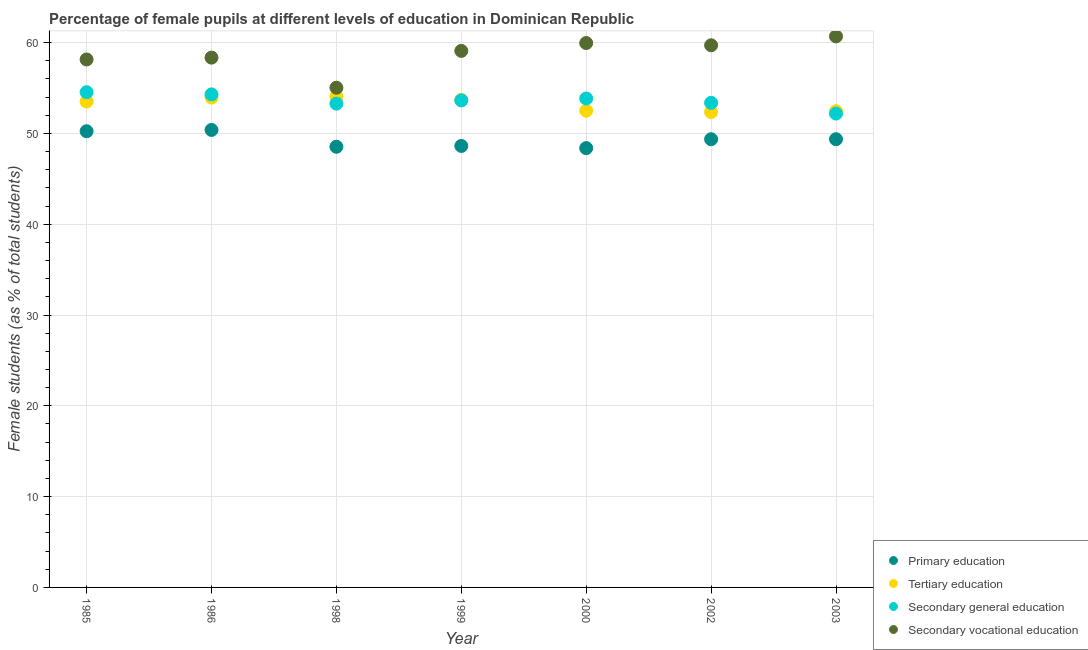How many different coloured dotlines are there?
Provide a short and direct response. 4. What is the percentage of female students in tertiary education in 1999?
Offer a very short reply. 53.7. Across all years, what is the maximum percentage of female students in secondary vocational education?
Your answer should be compact. 60.68. Across all years, what is the minimum percentage of female students in primary education?
Offer a terse response. 48.38. In which year was the percentage of female students in tertiary education maximum?
Your response must be concise. 1998. In which year was the percentage of female students in primary education minimum?
Your response must be concise. 2000. What is the total percentage of female students in primary education in the graph?
Give a very brief answer. 344.88. What is the difference between the percentage of female students in secondary vocational education in 1985 and that in 1986?
Offer a terse response. -0.2. What is the difference between the percentage of female students in tertiary education in 2002 and the percentage of female students in primary education in 1998?
Your response must be concise. 3.82. What is the average percentage of female students in tertiary education per year?
Your answer should be compact. 53.22. In the year 1999, what is the difference between the percentage of female students in tertiary education and percentage of female students in primary education?
Your response must be concise. 5.08. In how many years, is the percentage of female students in secondary education greater than 46 %?
Give a very brief answer. 7. What is the ratio of the percentage of female students in secondary education in 1985 to that in 2000?
Offer a very short reply. 1.01. Is the percentage of female students in secondary vocational education in 1998 less than that in 2002?
Your answer should be compact. Yes. Is the difference between the percentage of female students in secondary vocational education in 1985 and 2002 greater than the difference between the percentage of female students in primary education in 1985 and 2002?
Your response must be concise. No. What is the difference between the highest and the second highest percentage of female students in secondary education?
Your response must be concise. 0.24. What is the difference between the highest and the lowest percentage of female students in secondary vocational education?
Your response must be concise. 5.65. Is the sum of the percentage of female students in secondary education in 1986 and 2000 greater than the maximum percentage of female students in tertiary education across all years?
Provide a succinct answer. Yes. Is it the case that in every year, the sum of the percentage of female students in primary education and percentage of female students in tertiary education is greater than the sum of percentage of female students in secondary education and percentage of female students in secondary vocational education?
Give a very brief answer. Yes. Is it the case that in every year, the sum of the percentage of female students in primary education and percentage of female students in tertiary education is greater than the percentage of female students in secondary education?
Provide a short and direct response. Yes. Does the percentage of female students in secondary vocational education monotonically increase over the years?
Ensure brevity in your answer.  No. Is the percentage of female students in primary education strictly less than the percentage of female students in secondary vocational education over the years?
Your answer should be compact. Yes. How many years are there in the graph?
Offer a terse response. 7. What is the difference between two consecutive major ticks on the Y-axis?
Ensure brevity in your answer.  10. Are the values on the major ticks of Y-axis written in scientific E-notation?
Offer a very short reply. No. Does the graph contain grids?
Offer a terse response. Yes. Where does the legend appear in the graph?
Provide a succinct answer. Bottom right. How many legend labels are there?
Your response must be concise. 4. What is the title of the graph?
Make the answer very short. Percentage of female pupils at different levels of education in Dominican Republic. Does "Environmental sustainability" appear as one of the legend labels in the graph?
Offer a terse response. No. What is the label or title of the X-axis?
Ensure brevity in your answer.  Year. What is the label or title of the Y-axis?
Offer a terse response. Female students (as % of total students). What is the Female students (as % of total students) in Primary education in 1985?
Offer a very short reply. 50.24. What is the Female students (as % of total students) in Tertiary education in 1985?
Provide a succinct answer. 53.51. What is the Female students (as % of total students) in Secondary general education in 1985?
Offer a very short reply. 54.54. What is the Female students (as % of total students) in Secondary vocational education in 1985?
Provide a succinct answer. 58.14. What is the Female students (as % of total students) of Primary education in 1986?
Provide a succinct answer. 50.38. What is the Female students (as % of total students) of Tertiary education in 1986?
Your answer should be very brief. 53.95. What is the Female students (as % of total students) of Secondary general education in 1986?
Make the answer very short. 54.3. What is the Female students (as % of total students) of Secondary vocational education in 1986?
Your response must be concise. 58.35. What is the Female students (as % of total students) of Primary education in 1998?
Give a very brief answer. 48.53. What is the Female students (as % of total students) of Tertiary education in 1998?
Keep it short and to the point. 54.07. What is the Female students (as % of total students) in Secondary general education in 1998?
Keep it short and to the point. 53.28. What is the Female students (as % of total students) in Secondary vocational education in 1998?
Ensure brevity in your answer.  55.03. What is the Female students (as % of total students) of Primary education in 1999?
Your response must be concise. 48.62. What is the Female students (as % of total students) in Tertiary education in 1999?
Make the answer very short. 53.7. What is the Female students (as % of total students) of Secondary general education in 1999?
Provide a succinct answer. 53.64. What is the Female students (as % of total students) in Secondary vocational education in 1999?
Give a very brief answer. 59.09. What is the Female students (as % of total students) of Primary education in 2000?
Ensure brevity in your answer.  48.38. What is the Female students (as % of total students) of Tertiary education in 2000?
Give a very brief answer. 52.5. What is the Female students (as % of total students) of Secondary general education in 2000?
Provide a succinct answer. 53.85. What is the Female students (as % of total students) in Secondary vocational education in 2000?
Provide a short and direct response. 59.95. What is the Female students (as % of total students) of Primary education in 2002?
Your response must be concise. 49.36. What is the Female students (as % of total students) of Tertiary education in 2002?
Ensure brevity in your answer.  52.35. What is the Female students (as % of total students) in Secondary general education in 2002?
Make the answer very short. 53.37. What is the Female students (as % of total students) of Secondary vocational education in 2002?
Provide a short and direct response. 59.71. What is the Female students (as % of total students) of Primary education in 2003?
Keep it short and to the point. 49.36. What is the Female students (as % of total students) in Tertiary education in 2003?
Provide a short and direct response. 52.44. What is the Female students (as % of total students) in Secondary general education in 2003?
Offer a terse response. 52.19. What is the Female students (as % of total students) of Secondary vocational education in 2003?
Your answer should be very brief. 60.68. Across all years, what is the maximum Female students (as % of total students) of Primary education?
Your answer should be compact. 50.38. Across all years, what is the maximum Female students (as % of total students) in Tertiary education?
Keep it short and to the point. 54.07. Across all years, what is the maximum Female students (as % of total students) in Secondary general education?
Your answer should be very brief. 54.54. Across all years, what is the maximum Female students (as % of total students) of Secondary vocational education?
Provide a succinct answer. 60.68. Across all years, what is the minimum Female students (as % of total students) of Primary education?
Give a very brief answer. 48.38. Across all years, what is the minimum Female students (as % of total students) of Tertiary education?
Your response must be concise. 52.35. Across all years, what is the minimum Female students (as % of total students) of Secondary general education?
Give a very brief answer. 52.19. Across all years, what is the minimum Female students (as % of total students) of Secondary vocational education?
Offer a very short reply. 55.03. What is the total Female students (as % of total students) in Primary education in the graph?
Your response must be concise. 344.88. What is the total Female students (as % of total students) in Tertiary education in the graph?
Make the answer very short. 372.53. What is the total Female students (as % of total students) of Secondary general education in the graph?
Your answer should be very brief. 375.16. What is the total Female students (as % of total students) of Secondary vocational education in the graph?
Make the answer very short. 410.96. What is the difference between the Female students (as % of total students) of Primary education in 1985 and that in 1986?
Ensure brevity in your answer.  -0.14. What is the difference between the Female students (as % of total students) of Tertiary education in 1985 and that in 1986?
Provide a short and direct response. -0.44. What is the difference between the Female students (as % of total students) in Secondary general education in 1985 and that in 1986?
Ensure brevity in your answer.  0.24. What is the difference between the Female students (as % of total students) of Secondary vocational education in 1985 and that in 1986?
Offer a terse response. -0.2. What is the difference between the Female students (as % of total students) in Primary education in 1985 and that in 1998?
Keep it short and to the point. 1.71. What is the difference between the Female students (as % of total students) of Tertiary education in 1985 and that in 1998?
Give a very brief answer. -0.56. What is the difference between the Female students (as % of total students) in Secondary general education in 1985 and that in 1998?
Provide a short and direct response. 1.26. What is the difference between the Female students (as % of total students) in Secondary vocational education in 1985 and that in 1998?
Give a very brief answer. 3.11. What is the difference between the Female students (as % of total students) in Primary education in 1985 and that in 1999?
Offer a very short reply. 1.62. What is the difference between the Female students (as % of total students) in Tertiary education in 1985 and that in 1999?
Provide a short and direct response. -0.19. What is the difference between the Female students (as % of total students) of Secondary general education in 1985 and that in 1999?
Your answer should be compact. 0.91. What is the difference between the Female students (as % of total students) in Secondary vocational education in 1985 and that in 1999?
Give a very brief answer. -0.94. What is the difference between the Female students (as % of total students) in Primary education in 1985 and that in 2000?
Provide a succinct answer. 1.86. What is the difference between the Female students (as % of total students) of Tertiary education in 1985 and that in 2000?
Provide a succinct answer. 1.01. What is the difference between the Female students (as % of total students) of Secondary general education in 1985 and that in 2000?
Your answer should be compact. 0.69. What is the difference between the Female students (as % of total students) of Secondary vocational education in 1985 and that in 2000?
Give a very brief answer. -1.81. What is the difference between the Female students (as % of total students) in Primary education in 1985 and that in 2002?
Provide a short and direct response. 0.88. What is the difference between the Female students (as % of total students) of Tertiary education in 1985 and that in 2002?
Make the answer very short. 1.16. What is the difference between the Female students (as % of total students) in Secondary general education in 1985 and that in 2002?
Provide a succinct answer. 1.18. What is the difference between the Female students (as % of total students) in Secondary vocational education in 1985 and that in 2002?
Provide a succinct answer. -1.56. What is the difference between the Female students (as % of total students) of Primary education in 1985 and that in 2003?
Your answer should be compact. 0.88. What is the difference between the Female students (as % of total students) in Tertiary education in 1985 and that in 2003?
Your answer should be very brief. 1.07. What is the difference between the Female students (as % of total students) in Secondary general education in 1985 and that in 2003?
Provide a short and direct response. 2.36. What is the difference between the Female students (as % of total students) of Secondary vocational education in 1985 and that in 2003?
Your answer should be compact. -2.54. What is the difference between the Female students (as % of total students) of Primary education in 1986 and that in 1998?
Your response must be concise. 1.85. What is the difference between the Female students (as % of total students) in Tertiary education in 1986 and that in 1998?
Your answer should be very brief. -0.12. What is the difference between the Female students (as % of total students) in Secondary general education in 1986 and that in 1998?
Make the answer very short. 1.02. What is the difference between the Female students (as % of total students) in Secondary vocational education in 1986 and that in 1998?
Provide a succinct answer. 3.32. What is the difference between the Female students (as % of total students) of Primary education in 1986 and that in 1999?
Keep it short and to the point. 1.76. What is the difference between the Female students (as % of total students) in Tertiary education in 1986 and that in 1999?
Give a very brief answer. 0.25. What is the difference between the Female students (as % of total students) in Secondary general education in 1986 and that in 1999?
Make the answer very short. 0.66. What is the difference between the Female students (as % of total students) of Secondary vocational education in 1986 and that in 1999?
Ensure brevity in your answer.  -0.74. What is the difference between the Female students (as % of total students) in Primary education in 1986 and that in 2000?
Your response must be concise. 2. What is the difference between the Female students (as % of total students) of Tertiary education in 1986 and that in 2000?
Make the answer very short. 1.45. What is the difference between the Female students (as % of total students) of Secondary general education in 1986 and that in 2000?
Make the answer very short. 0.45. What is the difference between the Female students (as % of total students) of Secondary vocational education in 1986 and that in 2000?
Your response must be concise. -1.6. What is the difference between the Female students (as % of total students) in Primary education in 1986 and that in 2002?
Your answer should be very brief. 1.02. What is the difference between the Female students (as % of total students) in Tertiary education in 1986 and that in 2002?
Your response must be concise. 1.59. What is the difference between the Female students (as % of total students) of Secondary general education in 1986 and that in 2002?
Give a very brief answer. 0.93. What is the difference between the Female students (as % of total students) in Secondary vocational education in 1986 and that in 2002?
Your answer should be compact. -1.36. What is the difference between the Female students (as % of total students) of Primary education in 1986 and that in 2003?
Keep it short and to the point. 1.02. What is the difference between the Female students (as % of total students) in Tertiary education in 1986 and that in 2003?
Your answer should be compact. 1.51. What is the difference between the Female students (as % of total students) of Secondary general education in 1986 and that in 2003?
Provide a succinct answer. 2.11. What is the difference between the Female students (as % of total students) of Secondary vocational education in 1986 and that in 2003?
Ensure brevity in your answer.  -2.34. What is the difference between the Female students (as % of total students) in Primary education in 1998 and that in 1999?
Your answer should be very brief. -0.09. What is the difference between the Female students (as % of total students) in Tertiary education in 1998 and that in 1999?
Give a very brief answer. 0.37. What is the difference between the Female students (as % of total students) in Secondary general education in 1998 and that in 1999?
Your response must be concise. -0.36. What is the difference between the Female students (as % of total students) of Secondary vocational education in 1998 and that in 1999?
Give a very brief answer. -4.06. What is the difference between the Female students (as % of total students) of Primary education in 1998 and that in 2000?
Offer a terse response. 0.15. What is the difference between the Female students (as % of total students) in Tertiary education in 1998 and that in 2000?
Make the answer very short. 1.57. What is the difference between the Female students (as % of total students) in Secondary general education in 1998 and that in 2000?
Provide a short and direct response. -0.57. What is the difference between the Female students (as % of total students) in Secondary vocational education in 1998 and that in 2000?
Provide a succinct answer. -4.92. What is the difference between the Female students (as % of total students) in Primary education in 1998 and that in 2002?
Provide a succinct answer. -0.83. What is the difference between the Female students (as % of total students) in Tertiary education in 1998 and that in 2002?
Make the answer very short. 1.72. What is the difference between the Female students (as % of total students) in Secondary general education in 1998 and that in 2002?
Give a very brief answer. -0.09. What is the difference between the Female students (as % of total students) in Secondary vocational education in 1998 and that in 2002?
Offer a very short reply. -4.67. What is the difference between the Female students (as % of total students) of Primary education in 1998 and that in 2003?
Provide a short and direct response. -0.83. What is the difference between the Female students (as % of total students) of Tertiary education in 1998 and that in 2003?
Keep it short and to the point. 1.63. What is the difference between the Female students (as % of total students) in Secondary general education in 1998 and that in 2003?
Provide a short and direct response. 1.09. What is the difference between the Female students (as % of total students) in Secondary vocational education in 1998 and that in 2003?
Provide a short and direct response. -5.65. What is the difference between the Female students (as % of total students) of Primary education in 1999 and that in 2000?
Your answer should be compact. 0.24. What is the difference between the Female students (as % of total students) in Tertiary education in 1999 and that in 2000?
Give a very brief answer. 1.2. What is the difference between the Female students (as % of total students) in Secondary general education in 1999 and that in 2000?
Offer a very short reply. -0.21. What is the difference between the Female students (as % of total students) of Secondary vocational education in 1999 and that in 2000?
Provide a succinct answer. -0.86. What is the difference between the Female students (as % of total students) in Primary education in 1999 and that in 2002?
Provide a short and direct response. -0.74. What is the difference between the Female students (as % of total students) in Tertiary education in 1999 and that in 2002?
Provide a succinct answer. 1.34. What is the difference between the Female students (as % of total students) in Secondary general education in 1999 and that in 2002?
Provide a succinct answer. 0.27. What is the difference between the Female students (as % of total students) of Secondary vocational education in 1999 and that in 2002?
Make the answer very short. -0.62. What is the difference between the Female students (as % of total students) of Primary education in 1999 and that in 2003?
Provide a succinct answer. -0.74. What is the difference between the Female students (as % of total students) of Tertiary education in 1999 and that in 2003?
Your answer should be very brief. 1.26. What is the difference between the Female students (as % of total students) of Secondary general education in 1999 and that in 2003?
Keep it short and to the point. 1.45. What is the difference between the Female students (as % of total students) of Secondary vocational education in 1999 and that in 2003?
Offer a very short reply. -1.6. What is the difference between the Female students (as % of total students) of Primary education in 2000 and that in 2002?
Provide a succinct answer. -0.98. What is the difference between the Female students (as % of total students) in Tertiary education in 2000 and that in 2002?
Offer a terse response. 0.15. What is the difference between the Female students (as % of total students) in Secondary general education in 2000 and that in 2002?
Your response must be concise. 0.48. What is the difference between the Female students (as % of total students) of Secondary vocational education in 2000 and that in 2002?
Your answer should be compact. 0.25. What is the difference between the Female students (as % of total students) of Primary education in 2000 and that in 2003?
Keep it short and to the point. -0.98. What is the difference between the Female students (as % of total students) in Tertiary education in 2000 and that in 2003?
Give a very brief answer. 0.06. What is the difference between the Female students (as % of total students) of Secondary general education in 2000 and that in 2003?
Ensure brevity in your answer.  1.66. What is the difference between the Female students (as % of total students) in Secondary vocational education in 2000 and that in 2003?
Offer a very short reply. -0.73. What is the difference between the Female students (as % of total students) of Tertiary education in 2002 and that in 2003?
Give a very brief answer. -0.09. What is the difference between the Female students (as % of total students) of Secondary general education in 2002 and that in 2003?
Give a very brief answer. 1.18. What is the difference between the Female students (as % of total students) of Secondary vocational education in 2002 and that in 2003?
Your response must be concise. -0.98. What is the difference between the Female students (as % of total students) in Primary education in 1985 and the Female students (as % of total students) in Tertiary education in 1986?
Your answer should be compact. -3.71. What is the difference between the Female students (as % of total students) in Primary education in 1985 and the Female students (as % of total students) in Secondary general education in 1986?
Ensure brevity in your answer.  -4.06. What is the difference between the Female students (as % of total students) in Primary education in 1985 and the Female students (as % of total students) in Secondary vocational education in 1986?
Provide a succinct answer. -8.11. What is the difference between the Female students (as % of total students) of Tertiary education in 1985 and the Female students (as % of total students) of Secondary general education in 1986?
Give a very brief answer. -0.79. What is the difference between the Female students (as % of total students) of Tertiary education in 1985 and the Female students (as % of total students) of Secondary vocational education in 1986?
Provide a succinct answer. -4.84. What is the difference between the Female students (as % of total students) in Secondary general education in 1985 and the Female students (as % of total students) in Secondary vocational education in 1986?
Make the answer very short. -3.81. What is the difference between the Female students (as % of total students) of Primary education in 1985 and the Female students (as % of total students) of Tertiary education in 1998?
Provide a short and direct response. -3.83. What is the difference between the Female students (as % of total students) of Primary education in 1985 and the Female students (as % of total students) of Secondary general education in 1998?
Your answer should be compact. -3.04. What is the difference between the Female students (as % of total students) of Primary education in 1985 and the Female students (as % of total students) of Secondary vocational education in 1998?
Your answer should be very brief. -4.79. What is the difference between the Female students (as % of total students) in Tertiary education in 1985 and the Female students (as % of total students) in Secondary general education in 1998?
Make the answer very short. 0.23. What is the difference between the Female students (as % of total students) in Tertiary education in 1985 and the Female students (as % of total students) in Secondary vocational education in 1998?
Keep it short and to the point. -1.52. What is the difference between the Female students (as % of total students) in Secondary general education in 1985 and the Female students (as % of total students) in Secondary vocational education in 1998?
Offer a terse response. -0.49. What is the difference between the Female students (as % of total students) in Primary education in 1985 and the Female students (as % of total students) in Tertiary education in 1999?
Offer a very short reply. -3.46. What is the difference between the Female students (as % of total students) in Primary education in 1985 and the Female students (as % of total students) in Secondary general education in 1999?
Your answer should be very brief. -3.4. What is the difference between the Female students (as % of total students) in Primary education in 1985 and the Female students (as % of total students) in Secondary vocational education in 1999?
Provide a succinct answer. -8.85. What is the difference between the Female students (as % of total students) in Tertiary education in 1985 and the Female students (as % of total students) in Secondary general education in 1999?
Give a very brief answer. -0.12. What is the difference between the Female students (as % of total students) of Tertiary education in 1985 and the Female students (as % of total students) of Secondary vocational education in 1999?
Provide a short and direct response. -5.58. What is the difference between the Female students (as % of total students) in Secondary general education in 1985 and the Female students (as % of total students) in Secondary vocational education in 1999?
Provide a succinct answer. -4.55. What is the difference between the Female students (as % of total students) of Primary education in 1985 and the Female students (as % of total students) of Tertiary education in 2000?
Your answer should be compact. -2.26. What is the difference between the Female students (as % of total students) of Primary education in 1985 and the Female students (as % of total students) of Secondary general education in 2000?
Ensure brevity in your answer.  -3.61. What is the difference between the Female students (as % of total students) of Primary education in 1985 and the Female students (as % of total students) of Secondary vocational education in 2000?
Give a very brief answer. -9.71. What is the difference between the Female students (as % of total students) in Tertiary education in 1985 and the Female students (as % of total students) in Secondary general education in 2000?
Make the answer very short. -0.34. What is the difference between the Female students (as % of total students) of Tertiary education in 1985 and the Female students (as % of total students) of Secondary vocational education in 2000?
Give a very brief answer. -6.44. What is the difference between the Female students (as % of total students) in Secondary general education in 1985 and the Female students (as % of total students) in Secondary vocational education in 2000?
Your answer should be compact. -5.41. What is the difference between the Female students (as % of total students) in Primary education in 1985 and the Female students (as % of total students) in Tertiary education in 2002?
Give a very brief answer. -2.11. What is the difference between the Female students (as % of total students) of Primary education in 1985 and the Female students (as % of total students) of Secondary general education in 2002?
Offer a very short reply. -3.13. What is the difference between the Female students (as % of total students) in Primary education in 1985 and the Female students (as % of total students) in Secondary vocational education in 2002?
Make the answer very short. -9.47. What is the difference between the Female students (as % of total students) in Tertiary education in 1985 and the Female students (as % of total students) in Secondary general education in 2002?
Offer a terse response. 0.15. What is the difference between the Female students (as % of total students) of Tertiary education in 1985 and the Female students (as % of total students) of Secondary vocational education in 2002?
Provide a short and direct response. -6.19. What is the difference between the Female students (as % of total students) of Secondary general education in 1985 and the Female students (as % of total students) of Secondary vocational education in 2002?
Keep it short and to the point. -5.16. What is the difference between the Female students (as % of total students) in Primary education in 1985 and the Female students (as % of total students) in Tertiary education in 2003?
Your answer should be very brief. -2.2. What is the difference between the Female students (as % of total students) in Primary education in 1985 and the Female students (as % of total students) in Secondary general education in 2003?
Your answer should be very brief. -1.95. What is the difference between the Female students (as % of total students) of Primary education in 1985 and the Female students (as % of total students) of Secondary vocational education in 2003?
Offer a terse response. -10.44. What is the difference between the Female students (as % of total students) in Tertiary education in 1985 and the Female students (as % of total students) in Secondary general education in 2003?
Provide a succinct answer. 1.33. What is the difference between the Female students (as % of total students) in Tertiary education in 1985 and the Female students (as % of total students) in Secondary vocational education in 2003?
Make the answer very short. -7.17. What is the difference between the Female students (as % of total students) in Secondary general education in 1985 and the Female students (as % of total students) in Secondary vocational education in 2003?
Your answer should be very brief. -6.14. What is the difference between the Female students (as % of total students) of Primary education in 1986 and the Female students (as % of total students) of Tertiary education in 1998?
Offer a terse response. -3.69. What is the difference between the Female students (as % of total students) of Primary education in 1986 and the Female students (as % of total students) of Secondary general education in 1998?
Offer a terse response. -2.9. What is the difference between the Female students (as % of total students) in Primary education in 1986 and the Female students (as % of total students) in Secondary vocational education in 1998?
Keep it short and to the point. -4.65. What is the difference between the Female students (as % of total students) in Tertiary education in 1986 and the Female students (as % of total students) in Secondary general education in 1998?
Your response must be concise. 0.67. What is the difference between the Female students (as % of total students) in Tertiary education in 1986 and the Female students (as % of total students) in Secondary vocational education in 1998?
Provide a succinct answer. -1.08. What is the difference between the Female students (as % of total students) in Secondary general education in 1986 and the Female students (as % of total students) in Secondary vocational education in 1998?
Keep it short and to the point. -0.73. What is the difference between the Female students (as % of total students) in Primary education in 1986 and the Female students (as % of total students) in Tertiary education in 1999?
Your response must be concise. -3.32. What is the difference between the Female students (as % of total students) of Primary education in 1986 and the Female students (as % of total students) of Secondary general education in 1999?
Your answer should be compact. -3.25. What is the difference between the Female students (as % of total students) of Primary education in 1986 and the Female students (as % of total students) of Secondary vocational education in 1999?
Offer a terse response. -8.71. What is the difference between the Female students (as % of total students) in Tertiary education in 1986 and the Female students (as % of total students) in Secondary general education in 1999?
Your response must be concise. 0.31. What is the difference between the Female students (as % of total students) in Tertiary education in 1986 and the Female students (as % of total students) in Secondary vocational education in 1999?
Offer a very short reply. -5.14. What is the difference between the Female students (as % of total students) of Secondary general education in 1986 and the Female students (as % of total students) of Secondary vocational education in 1999?
Keep it short and to the point. -4.79. What is the difference between the Female students (as % of total students) of Primary education in 1986 and the Female students (as % of total students) of Tertiary education in 2000?
Provide a short and direct response. -2.12. What is the difference between the Female students (as % of total students) of Primary education in 1986 and the Female students (as % of total students) of Secondary general education in 2000?
Keep it short and to the point. -3.46. What is the difference between the Female students (as % of total students) in Primary education in 1986 and the Female students (as % of total students) in Secondary vocational education in 2000?
Give a very brief answer. -9.57. What is the difference between the Female students (as % of total students) of Tertiary education in 1986 and the Female students (as % of total students) of Secondary general education in 2000?
Your response must be concise. 0.1. What is the difference between the Female students (as % of total students) in Tertiary education in 1986 and the Female students (as % of total students) in Secondary vocational education in 2000?
Provide a short and direct response. -6.01. What is the difference between the Female students (as % of total students) in Secondary general education in 1986 and the Female students (as % of total students) in Secondary vocational education in 2000?
Provide a succinct answer. -5.65. What is the difference between the Female students (as % of total students) in Primary education in 1986 and the Female students (as % of total students) in Tertiary education in 2002?
Keep it short and to the point. -1.97. What is the difference between the Female students (as % of total students) in Primary education in 1986 and the Female students (as % of total students) in Secondary general education in 2002?
Ensure brevity in your answer.  -2.98. What is the difference between the Female students (as % of total students) of Primary education in 1986 and the Female students (as % of total students) of Secondary vocational education in 2002?
Provide a succinct answer. -9.32. What is the difference between the Female students (as % of total students) in Tertiary education in 1986 and the Female students (as % of total students) in Secondary general education in 2002?
Ensure brevity in your answer.  0.58. What is the difference between the Female students (as % of total students) in Tertiary education in 1986 and the Female students (as % of total students) in Secondary vocational education in 2002?
Ensure brevity in your answer.  -5.76. What is the difference between the Female students (as % of total students) in Secondary general education in 1986 and the Female students (as % of total students) in Secondary vocational education in 2002?
Keep it short and to the point. -5.41. What is the difference between the Female students (as % of total students) of Primary education in 1986 and the Female students (as % of total students) of Tertiary education in 2003?
Ensure brevity in your answer.  -2.06. What is the difference between the Female students (as % of total students) in Primary education in 1986 and the Female students (as % of total students) in Secondary general education in 2003?
Offer a very short reply. -1.8. What is the difference between the Female students (as % of total students) in Primary education in 1986 and the Female students (as % of total students) in Secondary vocational education in 2003?
Ensure brevity in your answer.  -10.3. What is the difference between the Female students (as % of total students) in Tertiary education in 1986 and the Female students (as % of total students) in Secondary general education in 2003?
Keep it short and to the point. 1.76. What is the difference between the Female students (as % of total students) in Tertiary education in 1986 and the Female students (as % of total students) in Secondary vocational education in 2003?
Keep it short and to the point. -6.74. What is the difference between the Female students (as % of total students) in Secondary general education in 1986 and the Female students (as % of total students) in Secondary vocational education in 2003?
Your answer should be very brief. -6.39. What is the difference between the Female students (as % of total students) in Primary education in 1998 and the Female students (as % of total students) in Tertiary education in 1999?
Make the answer very short. -5.17. What is the difference between the Female students (as % of total students) of Primary education in 1998 and the Female students (as % of total students) of Secondary general education in 1999?
Your response must be concise. -5.1. What is the difference between the Female students (as % of total students) of Primary education in 1998 and the Female students (as % of total students) of Secondary vocational education in 1999?
Make the answer very short. -10.56. What is the difference between the Female students (as % of total students) in Tertiary education in 1998 and the Female students (as % of total students) in Secondary general education in 1999?
Offer a very short reply. 0.44. What is the difference between the Female students (as % of total students) of Tertiary education in 1998 and the Female students (as % of total students) of Secondary vocational education in 1999?
Your response must be concise. -5.02. What is the difference between the Female students (as % of total students) of Secondary general education in 1998 and the Female students (as % of total students) of Secondary vocational education in 1999?
Your response must be concise. -5.81. What is the difference between the Female students (as % of total students) in Primary education in 1998 and the Female students (as % of total students) in Tertiary education in 2000?
Give a very brief answer. -3.97. What is the difference between the Female students (as % of total students) in Primary education in 1998 and the Female students (as % of total students) in Secondary general education in 2000?
Keep it short and to the point. -5.32. What is the difference between the Female students (as % of total students) in Primary education in 1998 and the Female students (as % of total students) in Secondary vocational education in 2000?
Offer a terse response. -11.42. What is the difference between the Female students (as % of total students) in Tertiary education in 1998 and the Female students (as % of total students) in Secondary general education in 2000?
Keep it short and to the point. 0.22. What is the difference between the Female students (as % of total students) of Tertiary education in 1998 and the Female students (as % of total students) of Secondary vocational education in 2000?
Offer a very short reply. -5.88. What is the difference between the Female students (as % of total students) of Secondary general education in 1998 and the Female students (as % of total students) of Secondary vocational education in 2000?
Make the answer very short. -6.67. What is the difference between the Female students (as % of total students) of Primary education in 1998 and the Female students (as % of total students) of Tertiary education in 2002?
Offer a very short reply. -3.82. What is the difference between the Female students (as % of total students) in Primary education in 1998 and the Female students (as % of total students) in Secondary general education in 2002?
Provide a short and direct response. -4.84. What is the difference between the Female students (as % of total students) of Primary education in 1998 and the Female students (as % of total students) of Secondary vocational education in 2002?
Offer a very short reply. -11.18. What is the difference between the Female students (as % of total students) of Tertiary education in 1998 and the Female students (as % of total students) of Secondary general education in 2002?
Give a very brief answer. 0.7. What is the difference between the Female students (as % of total students) in Tertiary education in 1998 and the Female students (as % of total students) in Secondary vocational education in 2002?
Make the answer very short. -5.64. What is the difference between the Female students (as % of total students) of Secondary general education in 1998 and the Female students (as % of total students) of Secondary vocational education in 2002?
Make the answer very short. -6.43. What is the difference between the Female students (as % of total students) of Primary education in 1998 and the Female students (as % of total students) of Tertiary education in 2003?
Provide a succinct answer. -3.91. What is the difference between the Female students (as % of total students) of Primary education in 1998 and the Female students (as % of total students) of Secondary general education in 2003?
Give a very brief answer. -3.66. What is the difference between the Female students (as % of total students) of Primary education in 1998 and the Female students (as % of total students) of Secondary vocational education in 2003?
Provide a succinct answer. -12.15. What is the difference between the Female students (as % of total students) of Tertiary education in 1998 and the Female students (as % of total students) of Secondary general education in 2003?
Your answer should be compact. 1.88. What is the difference between the Female students (as % of total students) in Tertiary education in 1998 and the Female students (as % of total students) in Secondary vocational education in 2003?
Make the answer very short. -6.61. What is the difference between the Female students (as % of total students) of Secondary general education in 1998 and the Female students (as % of total students) of Secondary vocational education in 2003?
Ensure brevity in your answer.  -7.4. What is the difference between the Female students (as % of total students) in Primary education in 1999 and the Female students (as % of total students) in Tertiary education in 2000?
Ensure brevity in your answer.  -3.88. What is the difference between the Female students (as % of total students) in Primary education in 1999 and the Female students (as % of total students) in Secondary general education in 2000?
Provide a short and direct response. -5.23. What is the difference between the Female students (as % of total students) in Primary education in 1999 and the Female students (as % of total students) in Secondary vocational education in 2000?
Your answer should be compact. -11.33. What is the difference between the Female students (as % of total students) in Tertiary education in 1999 and the Female students (as % of total students) in Secondary general education in 2000?
Give a very brief answer. -0.15. What is the difference between the Female students (as % of total students) in Tertiary education in 1999 and the Female students (as % of total students) in Secondary vocational education in 2000?
Provide a short and direct response. -6.25. What is the difference between the Female students (as % of total students) in Secondary general education in 1999 and the Female students (as % of total students) in Secondary vocational education in 2000?
Your response must be concise. -6.32. What is the difference between the Female students (as % of total students) in Primary education in 1999 and the Female students (as % of total students) in Tertiary education in 2002?
Provide a short and direct response. -3.73. What is the difference between the Female students (as % of total students) of Primary education in 1999 and the Female students (as % of total students) of Secondary general education in 2002?
Offer a very short reply. -4.75. What is the difference between the Female students (as % of total students) of Primary education in 1999 and the Female students (as % of total students) of Secondary vocational education in 2002?
Your answer should be very brief. -11.09. What is the difference between the Female students (as % of total students) of Tertiary education in 1999 and the Female students (as % of total students) of Secondary general education in 2002?
Provide a succinct answer. 0.33. What is the difference between the Female students (as % of total students) in Tertiary education in 1999 and the Female students (as % of total students) in Secondary vocational education in 2002?
Your answer should be compact. -6.01. What is the difference between the Female students (as % of total students) of Secondary general education in 1999 and the Female students (as % of total students) of Secondary vocational education in 2002?
Keep it short and to the point. -6.07. What is the difference between the Female students (as % of total students) of Primary education in 1999 and the Female students (as % of total students) of Tertiary education in 2003?
Provide a succinct answer. -3.82. What is the difference between the Female students (as % of total students) of Primary education in 1999 and the Female students (as % of total students) of Secondary general education in 2003?
Your answer should be compact. -3.57. What is the difference between the Female students (as % of total students) in Primary education in 1999 and the Female students (as % of total students) in Secondary vocational education in 2003?
Make the answer very short. -12.06. What is the difference between the Female students (as % of total students) of Tertiary education in 1999 and the Female students (as % of total students) of Secondary general education in 2003?
Your answer should be compact. 1.51. What is the difference between the Female students (as % of total students) of Tertiary education in 1999 and the Female students (as % of total students) of Secondary vocational education in 2003?
Make the answer very short. -6.99. What is the difference between the Female students (as % of total students) in Secondary general education in 1999 and the Female students (as % of total students) in Secondary vocational education in 2003?
Provide a succinct answer. -7.05. What is the difference between the Female students (as % of total students) of Primary education in 2000 and the Female students (as % of total students) of Tertiary education in 2002?
Give a very brief answer. -3.97. What is the difference between the Female students (as % of total students) of Primary education in 2000 and the Female students (as % of total students) of Secondary general education in 2002?
Offer a very short reply. -4.98. What is the difference between the Female students (as % of total students) in Primary education in 2000 and the Female students (as % of total students) in Secondary vocational education in 2002?
Make the answer very short. -11.32. What is the difference between the Female students (as % of total students) of Tertiary education in 2000 and the Female students (as % of total students) of Secondary general education in 2002?
Offer a very short reply. -0.87. What is the difference between the Female students (as % of total students) of Tertiary education in 2000 and the Female students (as % of total students) of Secondary vocational education in 2002?
Give a very brief answer. -7.21. What is the difference between the Female students (as % of total students) in Secondary general education in 2000 and the Female students (as % of total students) in Secondary vocational education in 2002?
Ensure brevity in your answer.  -5.86. What is the difference between the Female students (as % of total students) of Primary education in 2000 and the Female students (as % of total students) of Tertiary education in 2003?
Your answer should be very brief. -4.06. What is the difference between the Female students (as % of total students) of Primary education in 2000 and the Female students (as % of total students) of Secondary general education in 2003?
Your answer should be very brief. -3.8. What is the difference between the Female students (as % of total students) in Primary education in 2000 and the Female students (as % of total students) in Secondary vocational education in 2003?
Provide a succinct answer. -12.3. What is the difference between the Female students (as % of total students) of Tertiary education in 2000 and the Female students (as % of total students) of Secondary general education in 2003?
Ensure brevity in your answer.  0.31. What is the difference between the Female students (as % of total students) in Tertiary education in 2000 and the Female students (as % of total students) in Secondary vocational education in 2003?
Your answer should be very brief. -8.18. What is the difference between the Female students (as % of total students) of Secondary general education in 2000 and the Female students (as % of total students) of Secondary vocational education in 2003?
Make the answer very short. -6.84. What is the difference between the Female students (as % of total students) in Primary education in 2002 and the Female students (as % of total students) in Tertiary education in 2003?
Provide a succinct answer. -3.08. What is the difference between the Female students (as % of total students) of Primary education in 2002 and the Female students (as % of total students) of Secondary general education in 2003?
Offer a very short reply. -2.82. What is the difference between the Female students (as % of total students) in Primary education in 2002 and the Female students (as % of total students) in Secondary vocational education in 2003?
Make the answer very short. -11.32. What is the difference between the Female students (as % of total students) of Tertiary education in 2002 and the Female students (as % of total students) of Secondary general education in 2003?
Provide a succinct answer. 0.17. What is the difference between the Female students (as % of total students) of Tertiary education in 2002 and the Female students (as % of total students) of Secondary vocational education in 2003?
Provide a short and direct response. -8.33. What is the difference between the Female students (as % of total students) of Secondary general education in 2002 and the Female students (as % of total students) of Secondary vocational education in 2003?
Provide a short and direct response. -7.32. What is the average Female students (as % of total students) in Primary education per year?
Provide a short and direct response. 49.27. What is the average Female students (as % of total students) of Tertiary education per year?
Your response must be concise. 53.22. What is the average Female students (as % of total students) in Secondary general education per year?
Give a very brief answer. 53.59. What is the average Female students (as % of total students) in Secondary vocational education per year?
Ensure brevity in your answer.  58.71. In the year 1985, what is the difference between the Female students (as % of total students) of Primary education and Female students (as % of total students) of Tertiary education?
Your answer should be very brief. -3.27. In the year 1985, what is the difference between the Female students (as % of total students) in Primary education and Female students (as % of total students) in Secondary general education?
Keep it short and to the point. -4.3. In the year 1985, what is the difference between the Female students (as % of total students) of Primary education and Female students (as % of total students) of Secondary vocational education?
Your answer should be very brief. -7.9. In the year 1985, what is the difference between the Female students (as % of total students) of Tertiary education and Female students (as % of total students) of Secondary general education?
Your answer should be very brief. -1.03. In the year 1985, what is the difference between the Female students (as % of total students) in Tertiary education and Female students (as % of total students) in Secondary vocational education?
Keep it short and to the point. -4.63. In the year 1985, what is the difference between the Female students (as % of total students) of Secondary general education and Female students (as % of total students) of Secondary vocational education?
Provide a short and direct response. -3.6. In the year 1986, what is the difference between the Female students (as % of total students) in Primary education and Female students (as % of total students) in Tertiary education?
Your response must be concise. -3.56. In the year 1986, what is the difference between the Female students (as % of total students) of Primary education and Female students (as % of total students) of Secondary general education?
Your response must be concise. -3.92. In the year 1986, what is the difference between the Female students (as % of total students) in Primary education and Female students (as % of total students) in Secondary vocational education?
Ensure brevity in your answer.  -7.97. In the year 1986, what is the difference between the Female students (as % of total students) in Tertiary education and Female students (as % of total students) in Secondary general education?
Provide a succinct answer. -0.35. In the year 1986, what is the difference between the Female students (as % of total students) of Tertiary education and Female students (as % of total students) of Secondary vocational education?
Ensure brevity in your answer.  -4.4. In the year 1986, what is the difference between the Female students (as % of total students) in Secondary general education and Female students (as % of total students) in Secondary vocational education?
Offer a very short reply. -4.05. In the year 1998, what is the difference between the Female students (as % of total students) in Primary education and Female students (as % of total students) in Tertiary education?
Your answer should be very brief. -5.54. In the year 1998, what is the difference between the Female students (as % of total students) in Primary education and Female students (as % of total students) in Secondary general education?
Give a very brief answer. -4.75. In the year 1998, what is the difference between the Female students (as % of total students) of Primary education and Female students (as % of total students) of Secondary vocational education?
Provide a succinct answer. -6.5. In the year 1998, what is the difference between the Female students (as % of total students) in Tertiary education and Female students (as % of total students) in Secondary general education?
Give a very brief answer. 0.79. In the year 1998, what is the difference between the Female students (as % of total students) of Tertiary education and Female students (as % of total students) of Secondary vocational education?
Ensure brevity in your answer.  -0.96. In the year 1998, what is the difference between the Female students (as % of total students) in Secondary general education and Female students (as % of total students) in Secondary vocational education?
Provide a succinct answer. -1.75. In the year 1999, what is the difference between the Female students (as % of total students) in Primary education and Female students (as % of total students) in Tertiary education?
Offer a terse response. -5.08. In the year 1999, what is the difference between the Female students (as % of total students) of Primary education and Female students (as % of total students) of Secondary general education?
Your answer should be very brief. -5.01. In the year 1999, what is the difference between the Female students (as % of total students) in Primary education and Female students (as % of total students) in Secondary vocational education?
Your answer should be compact. -10.47. In the year 1999, what is the difference between the Female students (as % of total students) of Tertiary education and Female students (as % of total students) of Secondary general education?
Provide a succinct answer. 0.06. In the year 1999, what is the difference between the Female students (as % of total students) of Tertiary education and Female students (as % of total students) of Secondary vocational education?
Your response must be concise. -5.39. In the year 1999, what is the difference between the Female students (as % of total students) of Secondary general education and Female students (as % of total students) of Secondary vocational education?
Ensure brevity in your answer.  -5.45. In the year 2000, what is the difference between the Female students (as % of total students) in Primary education and Female students (as % of total students) in Tertiary education?
Keep it short and to the point. -4.12. In the year 2000, what is the difference between the Female students (as % of total students) of Primary education and Female students (as % of total students) of Secondary general education?
Keep it short and to the point. -5.47. In the year 2000, what is the difference between the Female students (as % of total students) in Primary education and Female students (as % of total students) in Secondary vocational education?
Offer a terse response. -11.57. In the year 2000, what is the difference between the Female students (as % of total students) in Tertiary education and Female students (as % of total students) in Secondary general education?
Provide a succinct answer. -1.35. In the year 2000, what is the difference between the Female students (as % of total students) in Tertiary education and Female students (as % of total students) in Secondary vocational education?
Your answer should be very brief. -7.45. In the year 2000, what is the difference between the Female students (as % of total students) in Secondary general education and Female students (as % of total students) in Secondary vocational education?
Offer a terse response. -6.11. In the year 2002, what is the difference between the Female students (as % of total students) in Primary education and Female students (as % of total students) in Tertiary education?
Provide a short and direct response. -2.99. In the year 2002, what is the difference between the Female students (as % of total students) in Primary education and Female students (as % of total students) in Secondary general education?
Your answer should be compact. -4. In the year 2002, what is the difference between the Female students (as % of total students) of Primary education and Female students (as % of total students) of Secondary vocational education?
Ensure brevity in your answer.  -10.34. In the year 2002, what is the difference between the Female students (as % of total students) of Tertiary education and Female students (as % of total students) of Secondary general education?
Ensure brevity in your answer.  -1.01. In the year 2002, what is the difference between the Female students (as % of total students) in Tertiary education and Female students (as % of total students) in Secondary vocational education?
Your response must be concise. -7.35. In the year 2002, what is the difference between the Female students (as % of total students) of Secondary general education and Female students (as % of total students) of Secondary vocational education?
Offer a terse response. -6.34. In the year 2003, what is the difference between the Female students (as % of total students) in Primary education and Female students (as % of total students) in Tertiary education?
Give a very brief answer. -3.08. In the year 2003, what is the difference between the Female students (as % of total students) in Primary education and Female students (as % of total students) in Secondary general education?
Provide a succinct answer. -2.82. In the year 2003, what is the difference between the Female students (as % of total students) in Primary education and Female students (as % of total students) in Secondary vocational education?
Offer a very short reply. -11.32. In the year 2003, what is the difference between the Female students (as % of total students) in Tertiary education and Female students (as % of total students) in Secondary general education?
Your answer should be compact. 0.26. In the year 2003, what is the difference between the Female students (as % of total students) of Tertiary education and Female students (as % of total students) of Secondary vocational education?
Provide a short and direct response. -8.24. In the year 2003, what is the difference between the Female students (as % of total students) in Secondary general education and Female students (as % of total students) in Secondary vocational education?
Offer a very short reply. -8.5. What is the ratio of the Female students (as % of total students) in Secondary vocational education in 1985 to that in 1986?
Ensure brevity in your answer.  1. What is the ratio of the Female students (as % of total students) in Primary education in 1985 to that in 1998?
Provide a short and direct response. 1.04. What is the ratio of the Female students (as % of total students) in Tertiary education in 1985 to that in 1998?
Make the answer very short. 0.99. What is the ratio of the Female students (as % of total students) of Secondary general education in 1985 to that in 1998?
Ensure brevity in your answer.  1.02. What is the ratio of the Female students (as % of total students) of Secondary vocational education in 1985 to that in 1998?
Offer a terse response. 1.06. What is the ratio of the Female students (as % of total students) in Tertiary education in 1985 to that in 1999?
Offer a very short reply. 1. What is the ratio of the Female students (as % of total students) of Secondary general education in 1985 to that in 1999?
Offer a terse response. 1.02. What is the ratio of the Female students (as % of total students) in Secondary vocational education in 1985 to that in 1999?
Offer a terse response. 0.98. What is the ratio of the Female students (as % of total students) of Primary education in 1985 to that in 2000?
Your answer should be compact. 1.04. What is the ratio of the Female students (as % of total students) of Tertiary education in 1985 to that in 2000?
Make the answer very short. 1.02. What is the ratio of the Female students (as % of total students) of Secondary general education in 1985 to that in 2000?
Make the answer very short. 1.01. What is the ratio of the Female students (as % of total students) in Secondary vocational education in 1985 to that in 2000?
Make the answer very short. 0.97. What is the ratio of the Female students (as % of total students) of Primary education in 1985 to that in 2002?
Offer a terse response. 1.02. What is the ratio of the Female students (as % of total students) of Tertiary education in 1985 to that in 2002?
Your response must be concise. 1.02. What is the ratio of the Female students (as % of total students) of Secondary vocational education in 1985 to that in 2002?
Your answer should be compact. 0.97. What is the ratio of the Female students (as % of total students) of Primary education in 1985 to that in 2003?
Offer a terse response. 1.02. What is the ratio of the Female students (as % of total students) in Tertiary education in 1985 to that in 2003?
Make the answer very short. 1.02. What is the ratio of the Female students (as % of total students) in Secondary general education in 1985 to that in 2003?
Provide a short and direct response. 1.05. What is the ratio of the Female students (as % of total students) of Secondary vocational education in 1985 to that in 2003?
Keep it short and to the point. 0.96. What is the ratio of the Female students (as % of total students) in Primary education in 1986 to that in 1998?
Make the answer very short. 1.04. What is the ratio of the Female students (as % of total students) in Secondary general education in 1986 to that in 1998?
Your answer should be compact. 1.02. What is the ratio of the Female students (as % of total students) of Secondary vocational education in 1986 to that in 1998?
Provide a succinct answer. 1.06. What is the ratio of the Female students (as % of total students) of Primary education in 1986 to that in 1999?
Your response must be concise. 1.04. What is the ratio of the Female students (as % of total students) of Secondary general education in 1986 to that in 1999?
Offer a terse response. 1.01. What is the ratio of the Female students (as % of total students) of Secondary vocational education in 1986 to that in 1999?
Offer a very short reply. 0.99. What is the ratio of the Female students (as % of total students) of Primary education in 1986 to that in 2000?
Give a very brief answer. 1.04. What is the ratio of the Female students (as % of total students) of Tertiary education in 1986 to that in 2000?
Ensure brevity in your answer.  1.03. What is the ratio of the Female students (as % of total students) of Secondary general education in 1986 to that in 2000?
Offer a terse response. 1.01. What is the ratio of the Female students (as % of total students) in Secondary vocational education in 1986 to that in 2000?
Your answer should be compact. 0.97. What is the ratio of the Female students (as % of total students) of Primary education in 1986 to that in 2002?
Offer a very short reply. 1.02. What is the ratio of the Female students (as % of total students) of Tertiary education in 1986 to that in 2002?
Your answer should be very brief. 1.03. What is the ratio of the Female students (as % of total students) of Secondary general education in 1986 to that in 2002?
Provide a succinct answer. 1.02. What is the ratio of the Female students (as % of total students) in Secondary vocational education in 1986 to that in 2002?
Make the answer very short. 0.98. What is the ratio of the Female students (as % of total students) in Primary education in 1986 to that in 2003?
Give a very brief answer. 1.02. What is the ratio of the Female students (as % of total students) in Tertiary education in 1986 to that in 2003?
Your answer should be very brief. 1.03. What is the ratio of the Female students (as % of total students) of Secondary general education in 1986 to that in 2003?
Make the answer very short. 1.04. What is the ratio of the Female students (as % of total students) in Secondary vocational education in 1986 to that in 2003?
Your answer should be very brief. 0.96. What is the ratio of the Female students (as % of total students) of Tertiary education in 1998 to that in 1999?
Offer a terse response. 1.01. What is the ratio of the Female students (as % of total students) of Secondary vocational education in 1998 to that in 1999?
Your answer should be very brief. 0.93. What is the ratio of the Female students (as % of total students) of Primary education in 1998 to that in 2000?
Offer a terse response. 1. What is the ratio of the Female students (as % of total students) of Tertiary education in 1998 to that in 2000?
Offer a terse response. 1.03. What is the ratio of the Female students (as % of total students) in Secondary vocational education in 1998 to that in 2000?
Give a very brief answer. 0.92. What is the ratio of the Female students (as % of total students) of Primary education in 1998 to that in 2002?
Give a very brief answer. 0.98. What is the ratio of the Female students (as % of total students) in Tertiary education in 1998 to that in 2002?
Provide a succinct answer. 1.03. What is the ratio of the Female students (as % of total students) in Secondary general education in 1998 to that in 2002?
Your answer should be very brief. 1. What is the ratio of the Female students (as % of total students) of Secondary vocational education in 1998 to that in 2002?
Provide a succinct answer. 0.92. What is the ratio of the Female students (as % of total students) of Primary education in 1998 to that in 2003?
Keep it short and to the point. 0.98. What is the ratio of the Female students (as % of total students) of Tertiary education in 1998 to that in 2003?
Make the answer very short. 1.03. What is the ratio of the Female students (as % of total students) in Secondary general education in 1998 to that in 2003?
Offer a terse response. 1.02. What is the ratio of the Female students (as % of total students) of Secondary vocational education in 1998 to that in 2003?
Ensure brevity in your answer.  0.91. What is the ratio of the Female students (as % of total students) in Primary education in 1999 to that in 2000?
Your answer should be compact. 1. What is the ratio of the Female students (as % of total students) in Tertiary education in 1999 to that in 2000?
Keep it short and to the point. 1.02. What is the ratio of the Female students (as % of total students) of Secondary general education in 1999 to that in 2000?
Ensure brevity in your answer.  1. What is the ratio of the Female students (as % of total students) in Secondary vocational education in 1999 to that in 2000?
Make the answer very short. 0.99. What is the ratio of the Female students (as % of total students) in Primary education in 1999 to that in 2002?
Your answer should be very brief. 0.98. What is the ratio of the Female students (as % of total students) in Tertiary education in 1999 to that in 2002?
Provide a succinct answer. 1.03. What is the ratio of the Female students (as % of total students) in Secondary general education in 1999 to that in 2002?
Provide a short and direct response. 1. What is the ratio of the Female students (as % of total students) of Primary education in 1999 to that in 2003?
Offer a very short reply. 0.98. What is the ratio of the Female students (as % of total students) in Secondary general education in 1999 to that in 2003?
Ensure brevity in your answer.  1.03. What is the ratio of the Female students (as % of total students) in Secondary vocational education in 1999 to that in 2003?
Keep it short and to the point. 0.97. What is the ratio of the Female students (as % of total students) of Primary education in 2000 to that in 2002?
Provide a short and direct response. 0.98. What is the ratio of the Female students (as % of total students) of Secondary general education in 2000 to that in 2002?
Give a very brief answer. 1.01. What is the ratio of the Female students (as % of total students) in Secondary vocational education in 2000 to that in 2002?
Ensure brevity in your answer.  1. What is the ratio of the Female students (as % of total students) of Primary education in 2000 to that in 2003?
Provide a succinct answer. 0.98. What is the ratio of the Female students (as % of total students) of Tertiary education in 2000 to that in 2003?
Give a very brief answer. 1. What is the ratio of the Female students (as % of total students) of Secondary general education in 2000 to that in 2003?
Give a very brief answer. 1.03. What is the ratio of the Female students (as % of total students) of Secondary vocational education in 2000 to that in 2003?
Your answer should be compact. 0.99. What is the ratio of the Female students (as % of total students) in Primary education in 2002 to that in 2003?
Make the answer very short. 1. What is the ratio of the Female students (as % of total students) in Secondary general education in 2002 to that in 2003?
Offer a very short reply. 1.02. What is the ratio of the Female students (as % of total students) in Secondary vocational education in 2002 to that in 2003?
Offer a terse response. 0.98. What is the difference between the highest and the second highest Female students (as % of total students) in Primary education?
Provide a succinct answer. 0.14. What is the difference between the highest and the second highest Female students (as % of total students) in Tertiary education?
Offer a terse response. 0.12. What is the difference between the highest and the second highest Female students (as % of total students) of Secondary general education?
Give a very brief answer. 0.24. What is the difference between the highest and the second highest Female students (as % of total students) in Secondary vocational education?
Your answer should be very brief. 0.73. What is the difference between the highest and the lowest Female students (as % of total students) of Primary education?
Your answer should be very brief. 2. What is the difference between the highest and the lowest Female students (as % of total students) of Tertiary education?
Give a very brief answer. 1.72. What is the difference between the highest and the lowest Female students (as % of total students) in Secondary general education?
Keep it short and to the point. 2.36. What is the difference between the highest and the lowest Female students (as % of total students) in Secondary vocational education?
Your response must be concise. 5.65. 